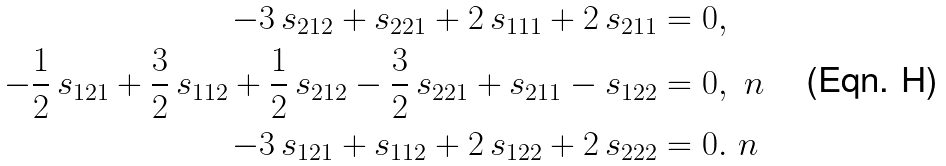Convert formula to latex. <formula><loc_0><loc_0><loc_500><loc_500>- 3 \, s _ { 2 1 2 } + s _ { 2 2 1 } + 2 \, s _ { 1 1 1 } + 2 \, s _ { 2 1 1 } & = 0 , \\ - \frac { 1 } { 2 } \, s _ { 1 2 1 } + \frac { 3 } { 2 } \, s _ { 1 1 2 } + \frac { 1 } { 2 } \, s _ { 2 1 2 } - \frac { 3 } { 2 } \, s _ { 2 2 1 } + s _ { 2 1 1 } - s _ { 1 2 2 } & = 0 , \ n \\ - 3 \, s _ { 1 2 1 } + s _ { 1 1 2 } + 2 \, s _ { 1 2 2 } + 2 \, s _ { 2 2 2 } & = 0 . \ n</formula> 